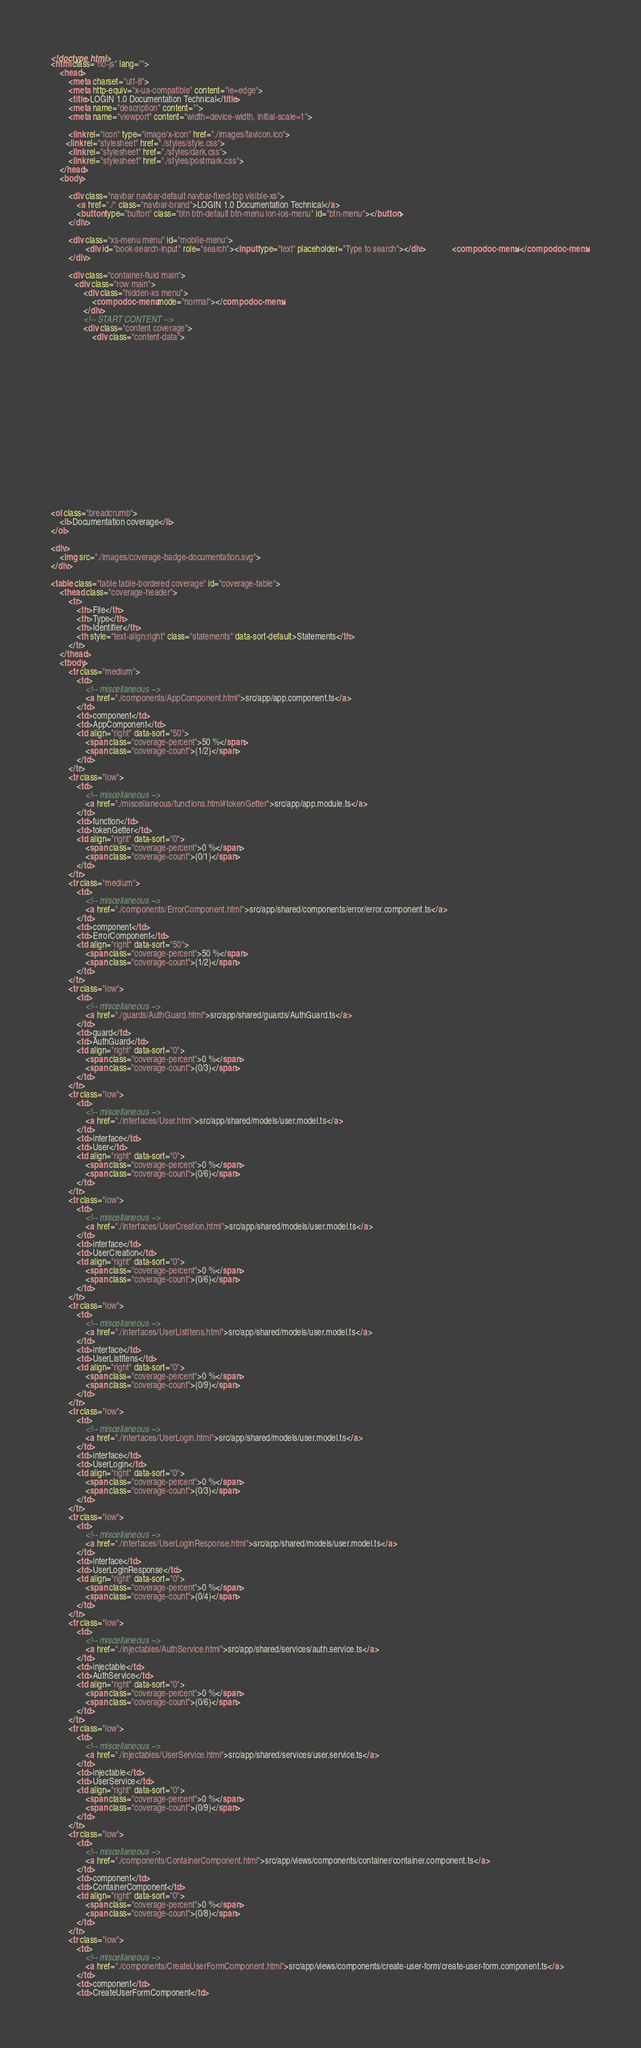<code> <loc_0><loc_0><loc_500><loc_500><_HTML_><!doctype html>
<html class="no-js" lang="">
    <head>
        <meta charset="utf-8">
        <meta http-equiv="x-ua-compatible" content="ie=edge">
        <title>LOGIN 1.0 Documentation Technical</title>
        <meta name="description" content="">
        <meta name="viewport" content="width=device-width, initial-scale=1">

        <link rel="icon" type="image/x-icon" href="./images/favicon.ico">
	   <link rel="stylesheet" href="./styles/style.css">
        <link rel="stylesheet" href="./styles/dark.css">
        <link rel="stylesheet" href="./styles/postmark.css">
    </head>
    <body>

        <div class="navbar navbar-default navbar-fixed-top visible-xs">
            <a href="./" class="navbar-brand">LOGIN 1.0 Documentation Technical</a>
            <button type="button" class="btn btn-default btn-menu ion-ios-menu" id="btn-menu"></button>
        </div>

        <div class="xs-menu menu" id="mobile-menu">
                <div id="book-search-input" role="search"><input type="text" placeholder="Type to search"></div>            <compodoc-menu></compodoc-menu>
        </div>

        <div class="container-fluid main">
           <div class="row main">
               <div class="hidden-xs menu">
                   <compodoc-menu mode="normal"></compodoc-menu>
               </div>
               <!-- START CONTENT -->
               <div class="content coverage">
                   <div class="content-data">



















<ol class="breadcrumb">
    <li>Documentation coverage</li>
</ol>

<div>
    <img src="./images/coverage-badge-documentation.svg">
</div>

<table class="table table-bordered coverage" id="coverage-table">
    <thead class="coverage-header">
        <tr>
            <th>File</th>
            <th>Type</th>
            <th>Identifier</th>
            <th style="text-align:right" class="statements" data-sort-default>Statements</th>
        </tr>
    </thead>
    <tbody>
        <tr class="medium">
            <td>
                <!-- miscellaneous -->
                <a href="./components/AppComponent.html">src/app/app.component.ts</a>
            </td>
            <td>component</td>
            <td>AppComponent</td>
            <td align="right" data-sort="50">
                <span class="coverage-percent">50 %</span>
                <span class="coverage-count">(1/2)</span>
            </td>
        </tr>
        <tr class="low">
            <td>
                <!-- miscellaneous -->
                <a href="./miscellaneous/functions.html#tokenGetter">src/app/app.module.ts</a>
            </td>
            <td>function</td>
            <td>tokenGetter</td>
            <td align="right" data-sort="0">
                <span class="coverage-percent">0 %</span>
                <span class="coverage-count">(0/1)</span>
            </td>
        </tr>
        <tr class="medium">
            <td>
                <!-- miscellaneous -->
                <a href="./components/ErrorComponent.html">src/app/shared/components/error/error.component.ts</a>
            </td>
            <td>component</td>
            <td>ErrorComponent</td>
            <td align="right" data-sort="50">
                <span class="coverage-percent">50 %</span>
                <span class="coverage-count">(1/2)</span>
            </td>
        </tr>
        <tr class="low">
            <td>
                <!-- miscellaneous -->
                <a href="./guards/AuthGuard.html">src/app/shared/guards/AuthGuard.ts</a>
            </td>
            <td>guard</td>
            <td>AuthGuard</td>
            <td align="right" data-sort="0">
                <span class="coverage-percent">0 %</span>
                <span class="coverage-count">(0/3)</span>
            </td>
        </tr>
        <tr class="low">
            <td>
                <!-- miscellaneous -->
                <a href="./interfaces/User.html">src/app/shared/models/user.model.ts</a>
            </td>
            <td>interface</td>
            <td>User</td>
            <td align="right" data-sort="0">
                <span class="coverage-percent">0 %</span>
                <span class="coverage-count">(0/6)</span>
            </td>
        </tr>
        <tr class="low">
            <td>
                <!-- miscellaneous -->
                <a href="./interfaces/UserCreation.html">src/app/shared/models/user.model.ts</a>
            </td>
            <td>interface</td>
            <td>UserCreation</td>
            <td align="right" data-sort="0">
                <span class="coverage-percent">0 %</span>
                <span class="coverage-count">(0/6)</span>
            </td>
        </tr>
        <tr class="low">
            <td>
                <!-- miscellaneous -->
                <a href="./interfaces/UserListItens.html">src/app/shared/models/user.model.ts</a>
            </td>
            <td>interface</td>
            <td>UserListItens</td>
            <td align="right" data-sort="0">
                <span class="coverage-percent">0 %</span>
                <span class="coverage-count">(0/9)</span>
            </td>
        </tr>
        <tr class="low">
            <td>
                <!-- miscellaneous -->
                <a href="./interfaces/UserLogin.html">src/app/shared/models/user.model.ts</a>
            </td>
            <td>interface</td>
            <td>UserLogin</td>
            <td align="right" data-sort="0">
                <span class="coverage-percent">0 %</span>
                <span class="coverage-count">(0/3)</span>
            </td>
        </tr>
        <tr class="low">
            <td>
                <!-- miscellaneous -->
                <a href="./interfaces/UserLoginResponse.html">src/app/shared/models/user.model.ts</a>
            </td>
            <td>interface</td>
            <td>UserLoginResponse</td>
            <td align="right" data-sort="0">
                <span class="coverage-percent">0 %</span>
                <span class="coverage-count">(0/4)</span>
            </td>
        </tr>
        <tr class="low">
            <td>
                <!-- miscellaneous -->
                <a href="./injectables/AuthService.html">src/app/shared/services/auth.service.ts</a>
            </td>
            <td>injectable</td>
            <td>AuthService</td>
            <td align="right" data-sort="0">
                <span class="coverage-percent">0 %</span>
                <span class="coverage-count">(0/6)</span>
            </td>
        </tr>
        <tr class="low">
            <td>
                <!-- miscellaneous -->
                <a href="./injectables/UserService.html">src/app/shared/services/user.service.ts</a>
            </td>
            <td>injectable</td>
            <td>UserService</td>
            <td align="right" data-sort="0">
                <span class="coverage-percent">0 %</span>
                <span class="coverage-count">(0/9)</span>
            </td>
        </tr>
        <tr class="low">
            <td>
                <!-- miscellaneous -->
                <a href="./components/ContainerComponent.html">src/app/views/components/container/container.component.ts</a>
            </td>
            <td>component</td>
            <td>ContainerComponent</td>
            <td align="right" data-sort="0">
                <span class="coverage-percent">0 %</span>
                <span class="coverage-count">(0/8)</span>
            </td>
        </tr>
        <tr class="low">
            <td>
                <!-- miscellaneous -->
                <a href="./components/CreateUserFormComponent.html">src/app/views/components/create-user-form/create-user-form.component.ts</a>
            </td>
            <td>component</td>
            <td>CreateUserFormComponent</td></code> 